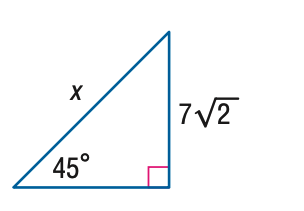Answer the mathemtical geometry problem and directly provide the correct option letter.
Question: Find x.
Choices: A: 7 B: 14 C: 14 \sqrt { 2 } D: 28 B 